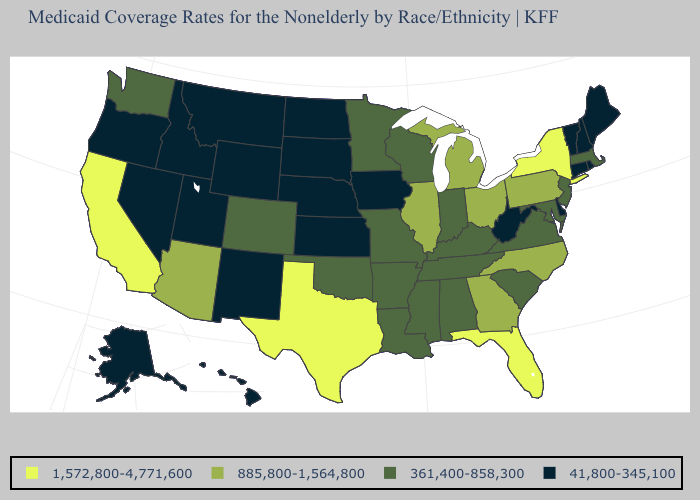Name the states that have a value in the range 361,400-858,300?
Write a very short answer. Alabama, Arkansas, Colorado, Indiana, Kentucky, Louisiana, Maryland, Massachusetts, Minnesota, Mississippi, Missouri, New Jersey, Oklahoma, South Carolina, Tennessee, Virginia, Washington, Wisconsin. Does Florida have the highest value in the USA?
Keep it brief. Yes. What is the value of Indiana?
Quick response, please. 361,400-858,300. Among the states that border Nebraska , does Missouri have the highest value?
Keep it brief. Yes. Which states have the lowest value in the Northeast?
Answer briefly. Connecticut, Maine, New Hampshire, Rhode Island, Vermont. Which states have the lowest value in the West?
Write a very short answer. Alaska, Hawaii, Idaho, Montana, Nevada, New Mexico, Oregon, Utah, Wyoming. How many symbols are there in the legend?
Keep it brief. 4. Which states have the lowest value in the USA?
Short answer required. Alaska, Connecticut, Delaware, Hawaii, Idaho, Iowa, Kansas, Maine, Montana, Nebraska, Nevada, New Hampshire, New Mexico, North Dakota, Oregon, Rhode Island, South Dakota, Utah, Vermont, West Virginia, Wyoming. What is the value of Maine?
Keep it brief. 41,800-345,100. What is the value of North Dakota?
Keep it brief. 41,800-345,100. What is the highest value in the MidWest ?
Keep it brief. 885,800-1,564,800. What is the value of North Dakota?
Keep it brief. 41,800-345,100. Does the map have missing data?
Give a very brief answer. No. Which states have the lowest value in the MidWest?
Quick response, please. Iowa, Kansas, Nebraska, North Dakota, South Dakota. 